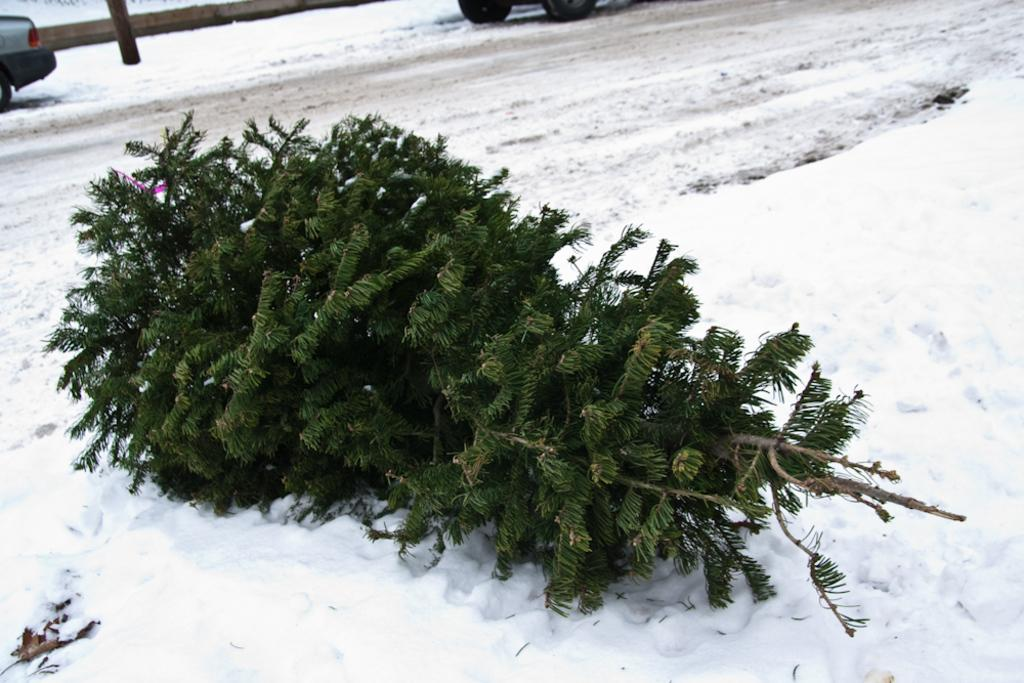What is the main subject of the image? There is a plant in the image. Where is the plant located? The plant is placed on a snowy surface. What can be seen in the background of the image? There are vehicles visible in the background of the image. How is the road condition in the image? The vehicles are on a snowy road. What type of cap is the plant wearing in the image? There is no cap present on the plant in the image. What is the purpose of the plant in the image? The image does not provide information about the purpose of the plant. 